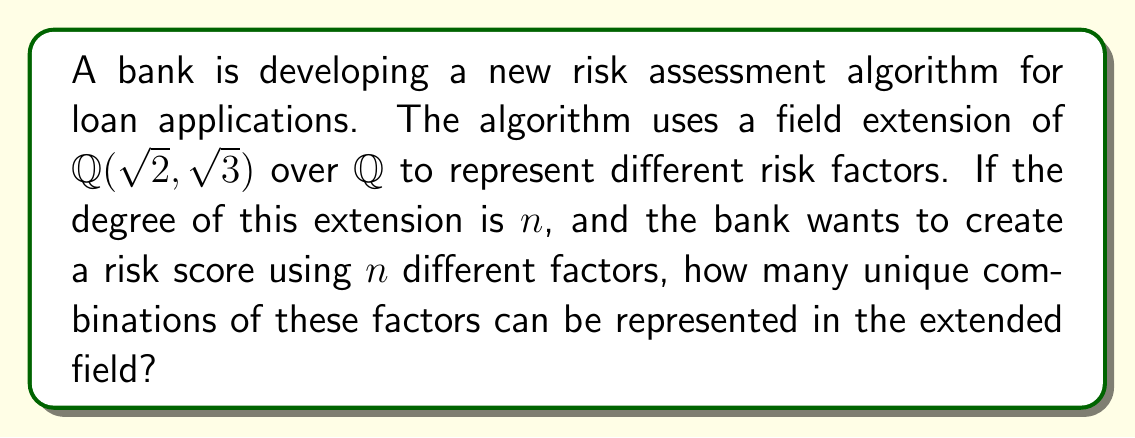Help me with this question. Let's approach this step-by-step:

1) First, we need to determine the degree of the extension $\mathbb{Q}(\sqrt{2}, \sqrt{3})$ over $\mathbb{Q}$.

2) The extension $\mathbb{Q}(\sqrt{2})$ over $\mathbb{Q}$ has degree 2, as does $\mathbb{Q}(\sqrt{3})$ over $\mathbb{Q}$.

3) To find the degree of $\mathbb{Q}(\sqrt{2}, \sqrt{3})$ over $\mathbb{Q}$, we need to determine if $\sqrt{3}$ is in $\mathbb{Q}(\sqrt{2})$. It isn't, so the extension $\mathbb{Q}(\sqrt{2}, \sqrt{3})$ over $\mathbb{Q}(\sqrt{2})$ also has degree 2.

4) By the tower law of field extensions, we have:
   $$[\mathbb{Q}(\sqrt{2}, \sqrt{3}) : \mathbb{Q}] = [\mathbb{Q}(\sqrt{2}, \sqrt{3}) : \mathbb{Q}(\sqrt{2})] \cdot [\mathbb{Q}(\sqrt{2}) : \mathbb{Q}] = 2 \cdot 2 = 4$$

5) So, the degree of the extension $n = 4$.

6) Now, in this extended field, each element can be uniquely represented as:
   $$a + b\sqrt{2} + c\sqrt{3} + d\sqrt{6}$$
   where $a, b, c, d \in \mathbb{Q}$

7) If we're using these 4 components to represent risk factors, and each factor can be either present (1) or absent (0), we have 2 choices for each of the 4 factors.

8) The total number of unique combinations is therefore $2^4 = 16$.
Answer: 16 